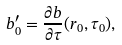Convert formula to latex. <formula><loc_0><loc_0><loc_500><loc_500>b _ { 0 } ^ { \prime } = \frac { \partial b } { \partial \tau } ( r _ { 0 } , \tau _ { 0 } ) ,</formula> 